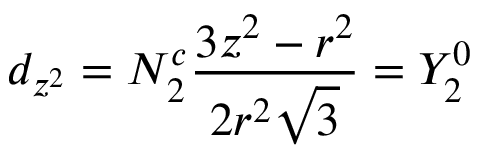<formula> <loc_0><loc_0><loc_500><loc_500>d _ { z ^ { 2 } } = N _ { 2 } ^ { c } { \frac { 3 z ^ { 2 } - r ^ { 2 } } { 2 r ^ { 2 } { \sqrt { 3 } } } } = Y _ { 2 } ^ { 0 }</formula> 